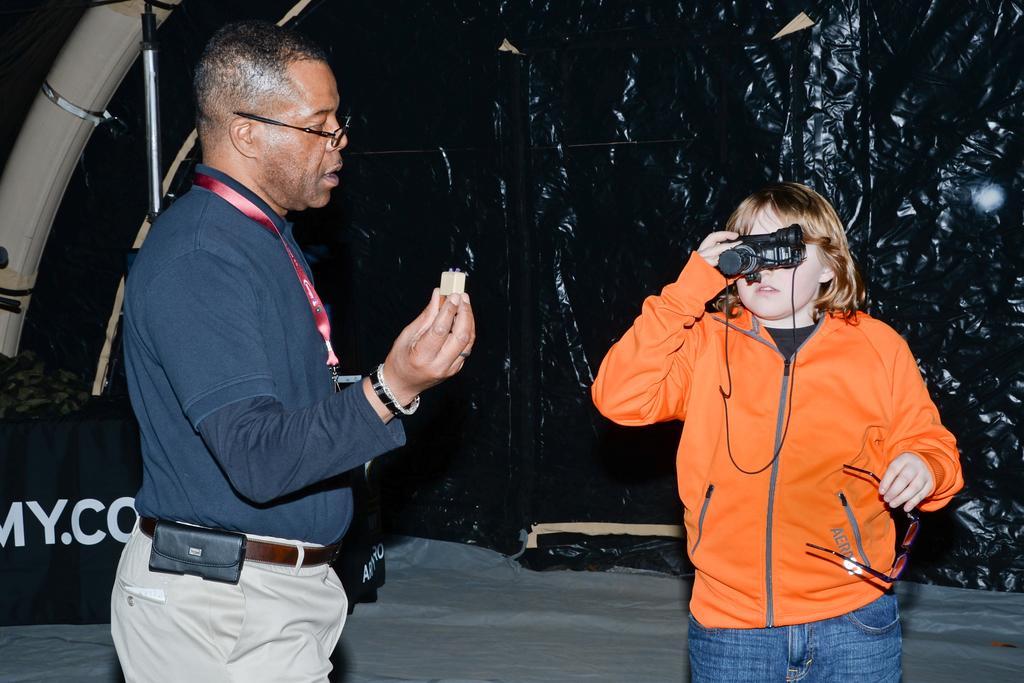Please provide a concise description of this image. In this image, we can see a person wearing clothes and holding an object with his hand. There is kid on the right side of the image holding spectacles and binocular with his hands. There is banner in the bottom left of the image. There is a pipe in the top left of the image. 